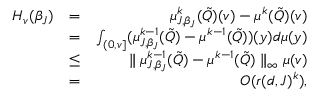<formula> <loc_0><loc_0><loc_500><loc_500>\begin{array} { r l r } { H _ { v } ( \beta _ { J } ) } & { = } & { \mu _ { J , \beta _ { J } } ^ { k } ( \tilde { Q } ) ( v ) - \mu ^ { k } ( \tilde { Q } ) ( v ) } \\ & { = } & { \int _ { ( 0 , v ] } ( \mu _ { J , \beta _ { J } } ^ { k - 1 } ( \tilde { Q } ) - \mu ^ { k - 1 } ( \tilde { Q } ) ) ( y ) d \mu ( y ) } \\ & { \leq } & { \| \mu _ { J , \beta _ { J } } ^ { k - 1 } ( \tilde { Q } ) - \mu ^ { k - 1 } ( \tilde { Q } ) \| _ { \infty } \mu ( v ) } \\ & { = } & { O ( r ( d , J ) ^ { k } ) , } \end{array}</formula> 